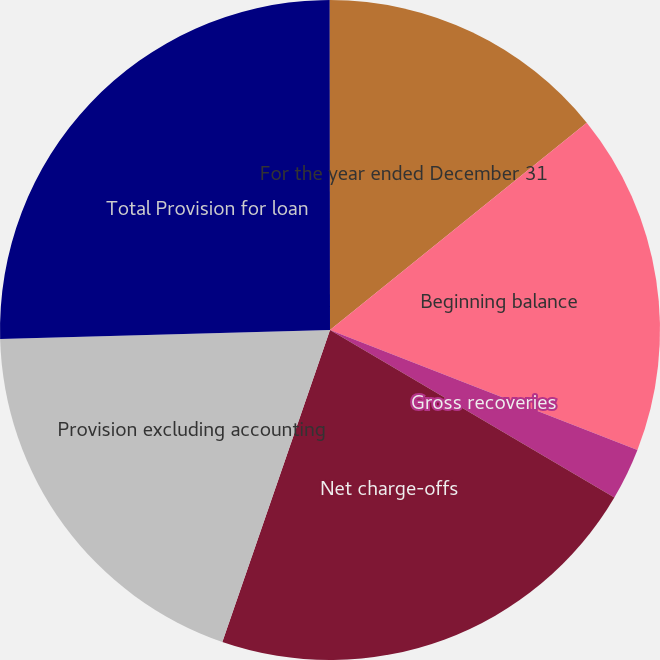Convert chart to OTSL. <chart><loc_0><loc_0><loc_500><loc_500><pie_chart><fcel>For the year ended December 31<fcel>Beginning balance<fcel>Gross recoveries<fcel>Net charge-offs<fcel>Provision excluding accounting<fcel>Total Provision for loan<fcel>Total Provision for<nl><fcel>14.19%<fcel>16.73%<fcel>2.55%<fcel>21.82%<fcel>19.27%<fcel>25.43%<fcel>0.01%<nl></chart> 